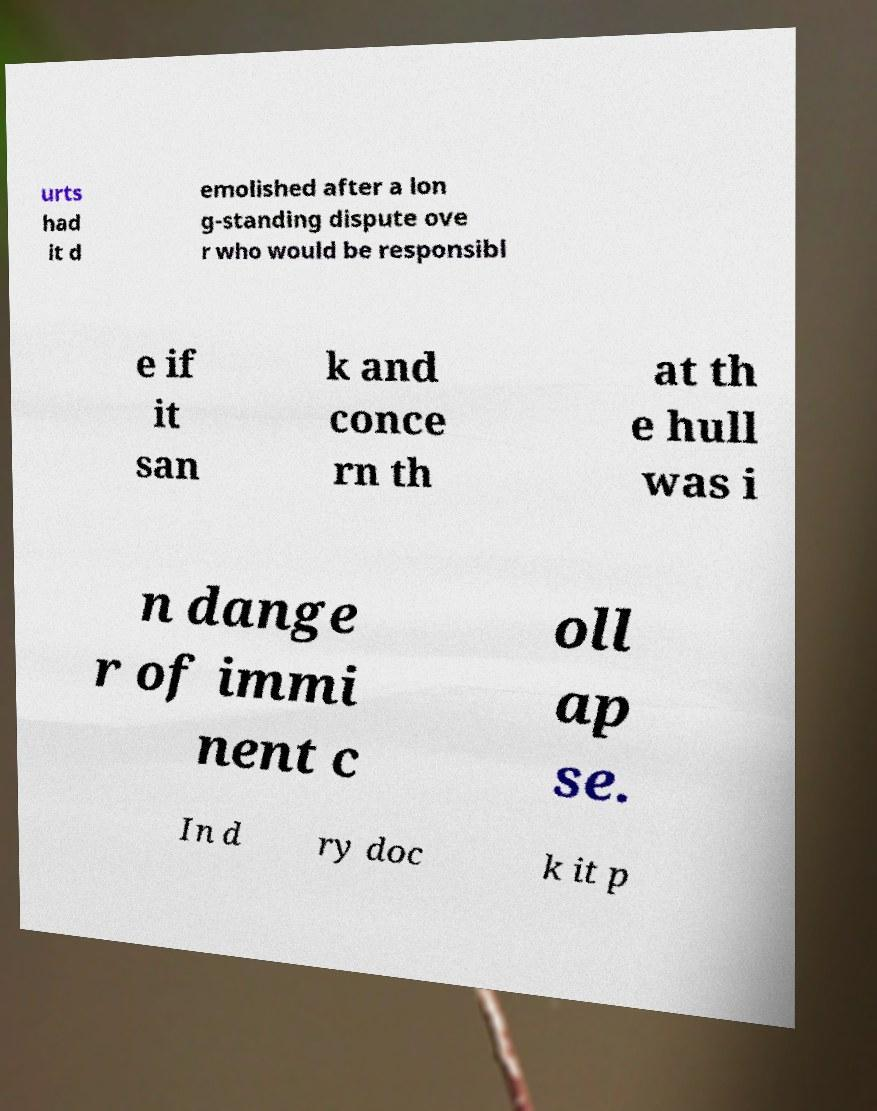There's text embedded in this image that I need extracted. Can you transcribe it verbatim? urts had it d emolished after a lon g-standing dispute ove r who would be responsibl e if it san k and conce rn th at th e hull was i n dange r of immi nent c oll ap se. In d ry doc k it p 